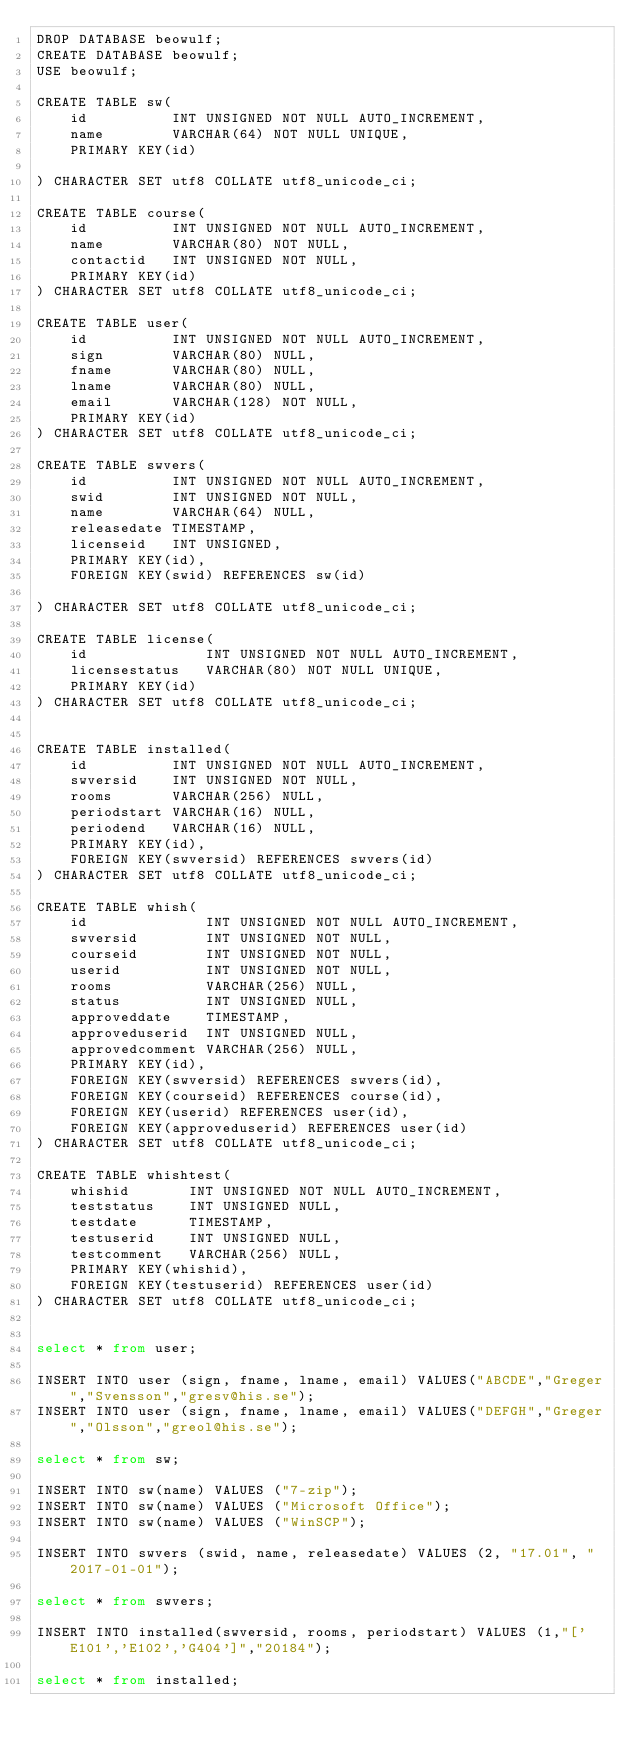<code> <loc_0><loc_0><loc_500><loc_500><_SQL_>DROP DATABASE beowulf;
CREATE DATABASE beowulf;
USE beowulf;

CREATE TABLE sw(
		id					INT UNSIGNED NOT NULL AUTO_INCREMENT,
		name    		VARCHAR(64) NOT NULL UNIQUE,
		PRIMARY KEY(id)

) CHARACTER SET utf8 COLLATE utf8_unicode_ci;

CREATE TABLE course(
		id					INT UNSIGNED NOT NULL AUTO_INCREMENT,
		name    		VARCHAR(80) NOT NULL,
		contactid		INT UNSIGNED NOT NULL,
		PRIMARY KEY(id)
) CHARACTER SET utf8 COLLATE utf8_unicode_ci;

CREATE TABLE user(
		id					INT UNSIGNED NOT NULL AUTO_INCREMENT,
		sign    		VARCHAR(80) NULL,
    fname   		VARCHAR(80) NULL,
    lname   		VARCHAR(80) NULL,
    email   		VARCHAR(128) NOT NULL,    
		PRIMARY KEY(id)
) CHARACTER SET utf8 COLLATE utf8_unicode_ci;

CREATE TABLE swvers(
		id					INT UNSIGNED NOT NULL AUTO_INCREMENT,
		swid		    INT UNSIGNED NOT NULL,
		name    		VARCHAR(64) NULL,
		releasedate TIMESTAMP,
		licenseid		INT UNSIGNED,
		PRIMARY KEY(id),
    FOREIGN KEY(swid) REFERENCES sw(id)

) CHARACTER SET utf8 COLLATE utf8_unicode_ci;

CREATE TABLE license(
		id              INT UNSIGNED NOT NULL AUTO_INCREMENT,
		licensestatus	  VARCHAR(80) NOT NULL UNIQUE,
		PRIMARY KEY(id)
) CHARACTER SET utf8 COLLATE utf8_unicode_ci;


CREATE TABLE installed(
		id					INT UNSIGNED NOT NULL AUTO_INCREMENT,
		swversid		INT UNSIGNED NOT NULL,
		rooms   		VARCHAR(256) NULL,
		periodstart	VARCHAR(16) NULL,
		periodend		VARCHAR(16) NULL,
		PRIMARY KEY(id),
    FOREIGN KEY(swversid) REFERENCES swvers(id)
) CHARACTER SET utf8 COLLATE utf8_unicode_ci;

CREATE TABLE whish(
		id              INT UNSIGNED NOT NULL AUTO_INCREMENT,
		swversid    		INT UNSIGNED NOT NULL,
		courseid		    INT UNSIGNED NOT NULL,
		userid          INT UNSIGNED NOT NULL,
		rooms					  VARCHAR(256) NULL,
		status		      INT UNSIGNED NULL,
		approveddate    TIMESTAMP,
		approveduserid  INT UNSIGNED NULL,
		approvedcomment	VARCHAR(256) NULL,
		PRIMARY KEY(id),
    FOREIGN KEY(swversid) REFERENCES swvers(id),
    FOREIGN KEY(courseid) REFERENCES course(id),
    FOREIGN KEY(userid) REFERENCES user(id),
    FOREIGN KEY(approveduserid) REFERENCES user(id)
) CHARACTER SET utf8 COLLATE utf8_unicode_ci;

CREATE TABLE whishtest(
		whishid				INT UNSIGNED NOT NULL AUTO_INCREMENT,
		teststatus		INT UNSIGNED NULL,
		testdate      TIMESTAMP,
		testuserid    INT UNSIGNED NULL,
		testcomment		VARCHAR(256) NULL,
		PRIMARY KEY(whishid),
    FOREIGN KEY(testuserid) REFERENCES user(id)
) CHARACTER SET utf8 COLLATE utf8_unicode_ci;


select * from user;

INSERT INTO user (sign, fname, lname, email) VALUES("ABCDE","Greger","Svensson","gresv@his.se");
INSERT INTO user (sign, fname, lname, email) VALUES("DEFGH","Greger","Olsson","greol@his.se");

select * from sw;

INSERT INTO sw(name) VALUES ("7-zip");
INSERT INTO sw(name) VALUES ("Microsoft Office");
INSERT INTO sw(name) VALUES ("WinSCP");

INSERT INTO swvers (swid, name, releasedate) VALUES (2, "17.01", "2017-01-01");

select * from swvers;

INSERT INTO installed(swversid, rooms, periodstart) VALUES (1,"['E101','E102','G404']","20184");

select * from installed;





</code> 